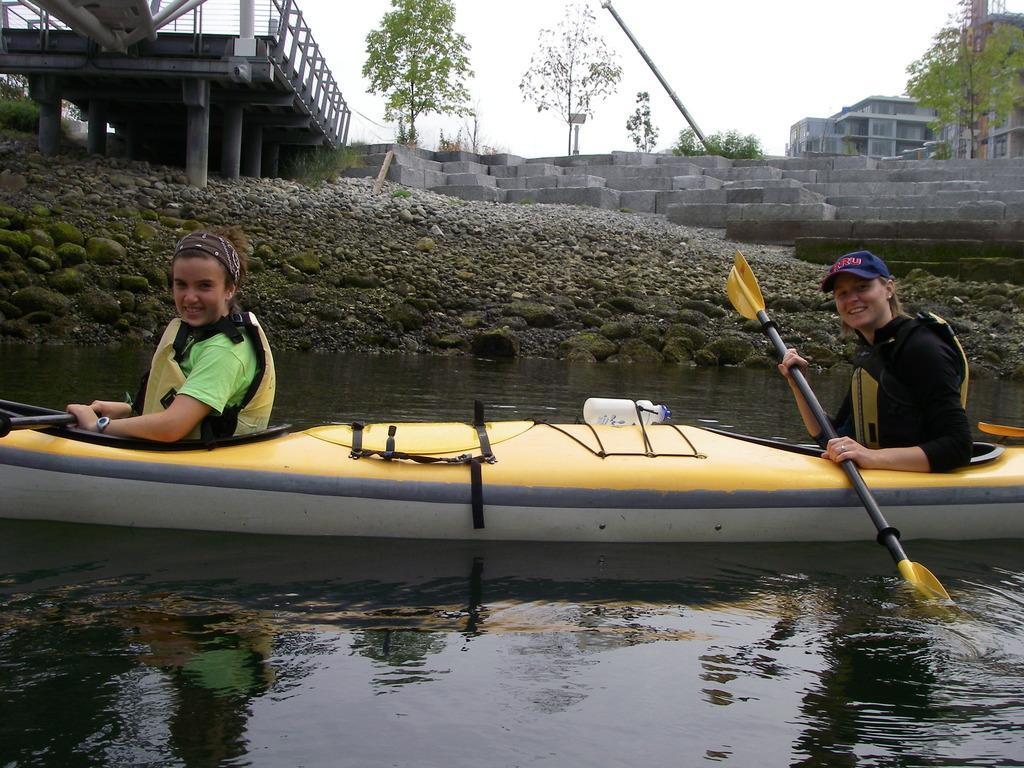In one or two sentences, can you explain what this image depicts? In the center of the image there are two people sitting in a boat and holding a paddle. At the bottom of the image there is water. In the background of the image there is a bridge,trees,buildings and staircase. 